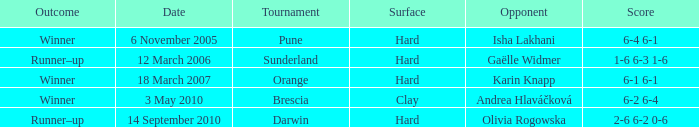When was the tournament at Orange? 18 March 2007. 